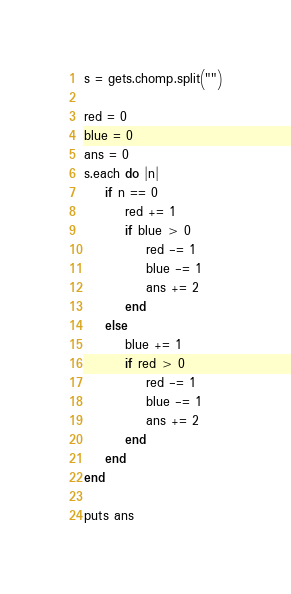Convert code to text. <code><loc_0><loc_0><loc_500><loc_500><_Ruby_>s = gets.chomp.split("")

red = 0
blue = 0
ans = 0
s.each do |n|
    if n == 0
        red += 1
        if blue > 0
            red -= 1
            blue -= 1
            ans += 2
        end
    else
        blue += 1
        if red > 0
            red -= 1
            blue -= 1
            ans += 2
        end
    end
end

puts ans
</code> 